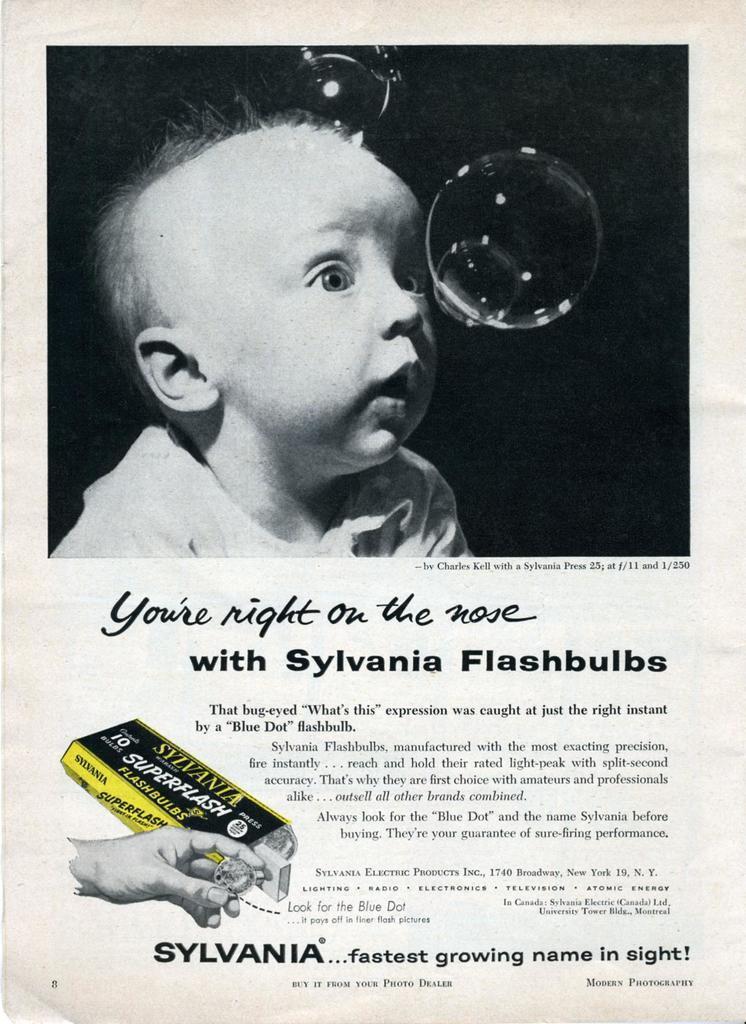Describe this image in one or two sentences. In this image we can see the poster with text and images. In this poster we can see the black and white picture of a baby. One person's hand holding one object. 